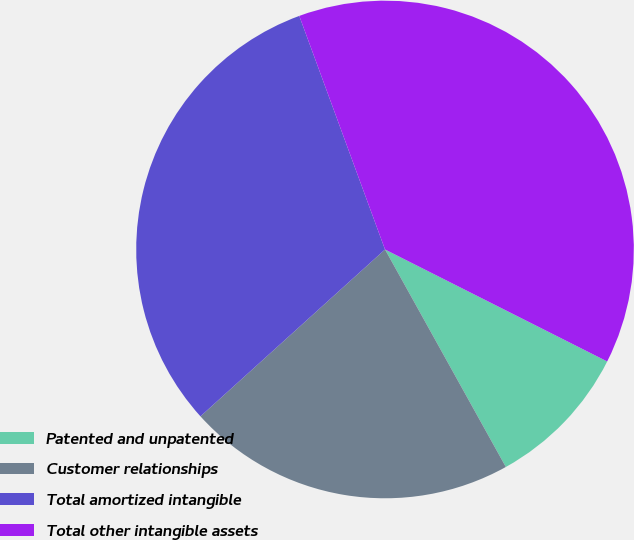<chart> <loc_0><loc_0><loc_500><loc_500><pie_chart><fcel>Patented and unpatented<fcel>Customer relationships<fcel>Total amortized intangible<fcel>Total other intangible assets<nl><fcel>9.5%<fcel>21.37%<fcel>31.1%<fcel>38.03%<nl></chart> 